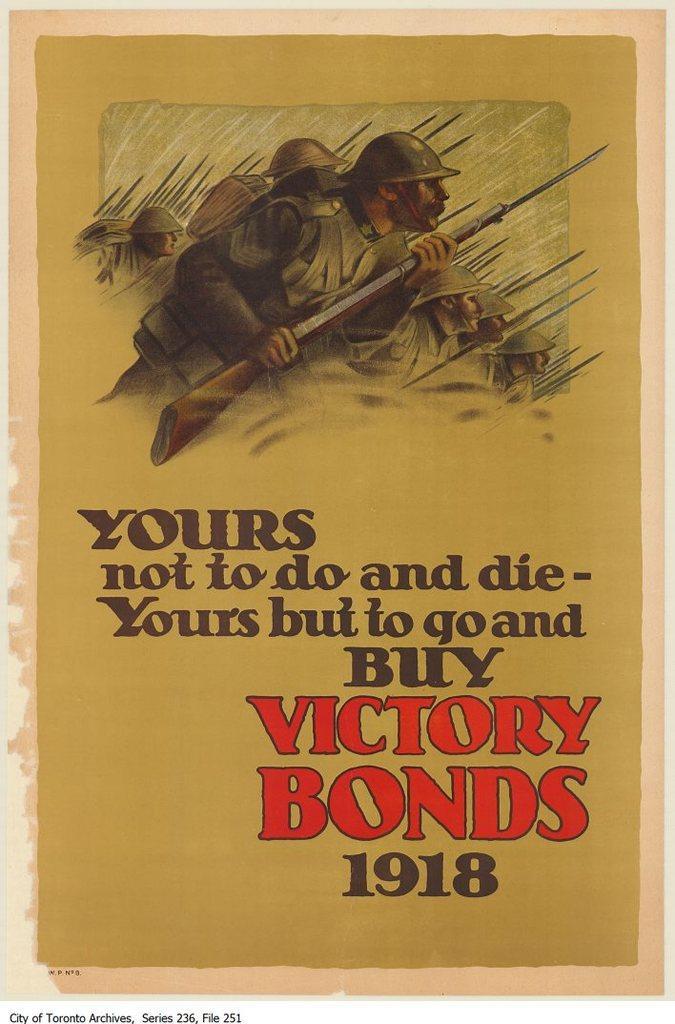Provide a one-sentence caption for the provided image. A 1918 advertisement to go out and buy victory bonds. 